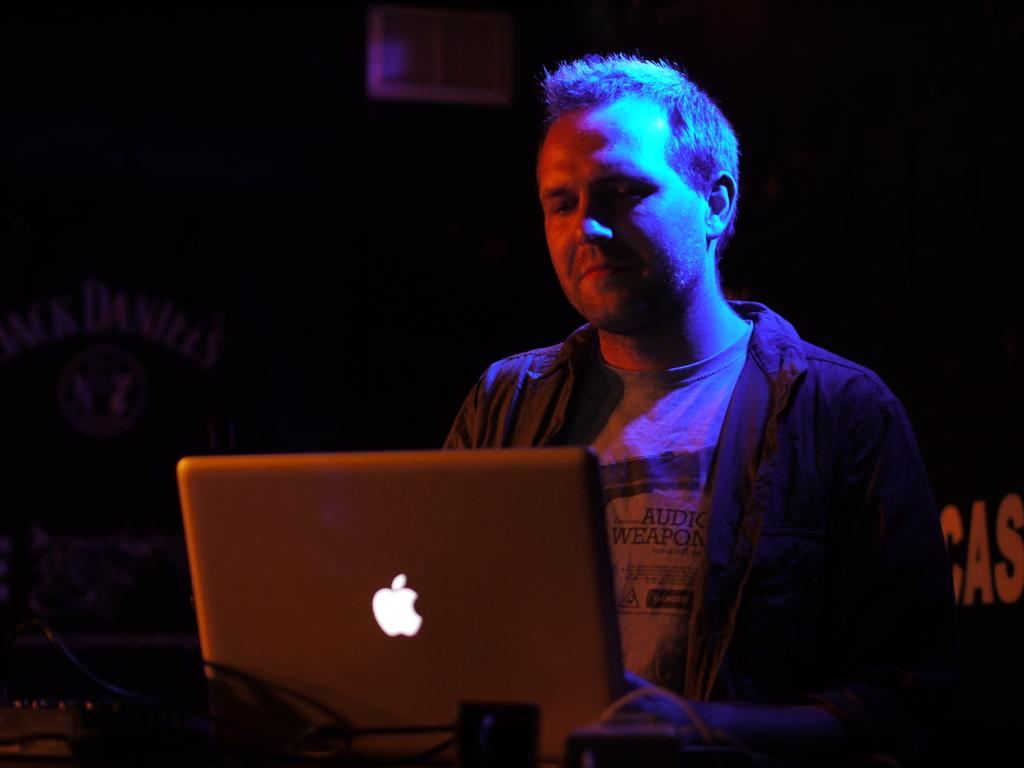What is the main subject in the center of the image? There is a person in the center of the image holding a laptop. What can be seen in the background of the image? There is a window and a board in the background of the image. What is present at the bottom of the image? There are wires at the bottom of the image. What rule is being enforced by the person's skin in the image? There is no mention of any rule or enforcement in the image, and the person's skin is not depicted as enforcing anything. 